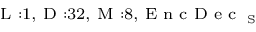<formula> <loc_0><loc_0><loc_500><loc_500>_ { L \colon 1 , D \colon 3 2 , M \colon 8 , E n c D e c _ { S } }</formula> 